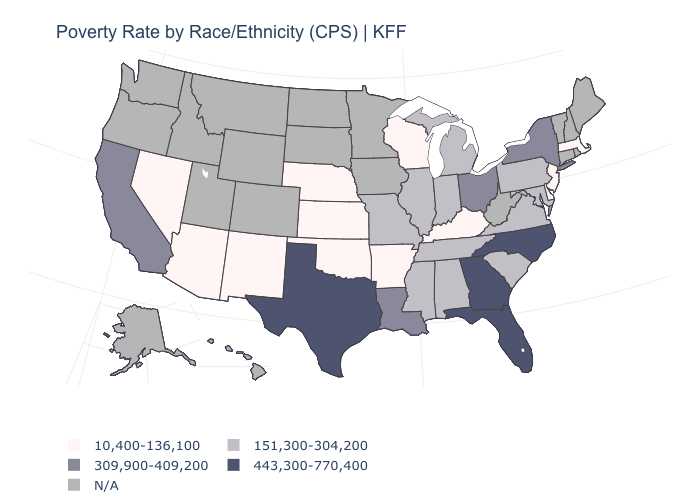Does Florida have the lowest value in the USA?
Answer briefly. No. Is the legend a continuous bar?
Be succinct. No. Does the first symbol in the legend represent the smallest category?
Quick response, please. Yes. Name the states that have a value in the range 443,300-770,400?
Quick response, please. Florida, Georgia, North Carolina, Texas. Name the states that have a value in the range 10,400-136,100?
Keep it brief. Arizona, Arkansas, Delaware, Kansas, Kentucky, Massachusetts, Nebraska, Nevada, New Jersey, New Mexico, Oklahoma, Wisconsin. What is the lowest value in states that border Missouri?
Answer briefly. 10,400-136,100. What is the value of Utah?
Be succinct. N/A. Name the states that have a value in the range 443,300-770,400?
Quick response, please. Florida, Georgia, North Carolina, Texas. What is the value of North Dakota?
Be succinct. N/A. Does the map have missing data?
Quick response, please. Yes. What is the highest value in states that border Ohio?
Concise answer only. 151,300-304,200. Name the states that have a value in the range 443,300-770,400?
Quick response, please. Florida, Georgia, North Carolina, Texas. Among the states that border Massachusetts , which have the lowest value?
Write a very short answer. New York. What is the lowest value in the USA?
Answer briefly. 10,400-136,100. Among the states that border Nevada , does Arizona have the lowest value?
Keep it brief. Yes. 